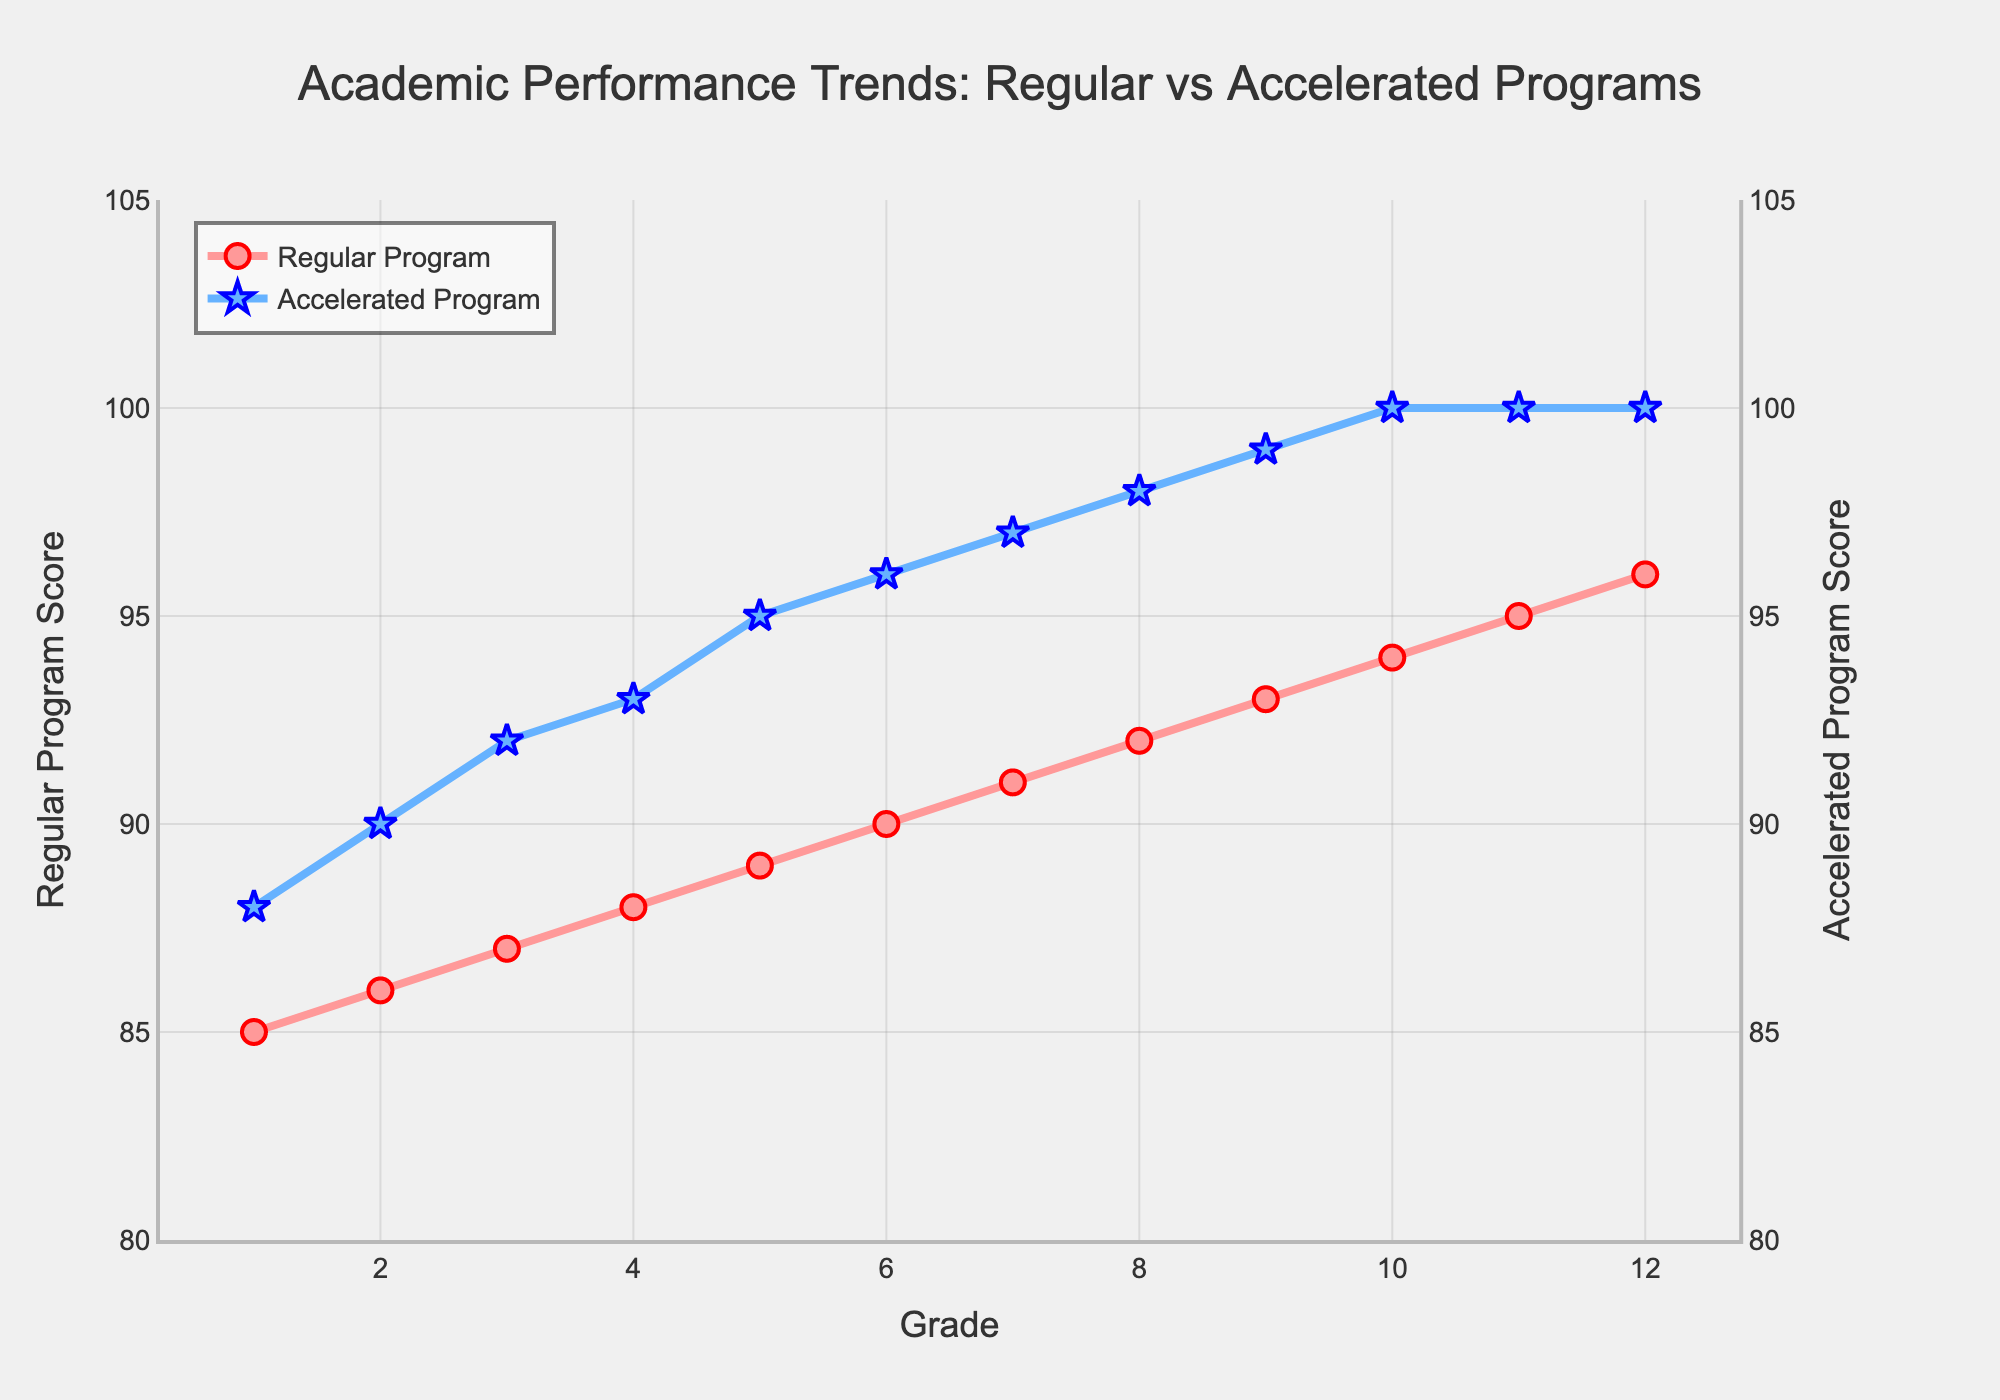Which program shows a more consistent trend in academic performance from grade 1 to grade 12? To determine consistency, observe the smoothness of the line plot. The Regular Program shows a gradual, steady increase in scores, while the Accelerated Program also shows a steady increase but with a slightly more rapid rise. Both are consistent, but the Regular Program has a slightly smoother trend.
Answer: Regular Program At which grade does the Regular Program achieve a score of 90, and how does this compare to the Accelerated Program’s score at the same grade? Look at the plot to find where the Regular Program line intersects the score of 90. This happens at grade 6. The Accelerated Program score at grade 6 is 96.
Answer: Grade 6, 96 What is the difference in performance between the Regular Program and the Accelerated Program at grade 10? At grade 10, observe the y-values for both programs. The Regular Program score is 94, and the Accelerated Program score is 100. Subtract the Regular Program score from the Accelerated Program score: 100 - 94 = 6.
Answer: 6 What is the average performance score of the Accelerated Program from grades 1 through 12? Sum the scores for the Accelerated Program from grades 1 to 12 and divide by 12. (88 + 90 + 92 + 93 + 95 + 96 + 97 + 98 + 99 + 100 + 100 + 100) / 12 = 94.083.
Answer: 94.083 How do the trends of the Regular Program and Accelerated Program differ visually? The Regular Program line is red with circle markers and shows a gradual upward trend. The Accelerated Program line is blue with star markers and shows a steeper upward trend in performance and reaches 100 by grade 10, remaining constant thereafter.
Answer: Red circle markers for Regular Program, blue star markers for Accelerated Program At what grade does the Accelerated Program reach a score of 100, and what is the Regular Program’s score at that grade? The Accelerated Program reaches a score of 100 at grade 10. The Regular Program’s score at grade 10 is 94.
Answer: Grade 10, 94 What is the overall trend in average scores across all grades for both programs? Calculate the average score across all grades for both programs. Regular: (85 + 86 + 87 + 88 + 89 + 90 + 91 + 92 + 93 + 94 + 95 + 96) / 12 = 90.25. Accelerated: (88 + 90 + 92 + 93 + 95 + 96 + 97 + 98 + 99 + 100 + 100 + 100) / 12 = 94.083. Both show an increasing trend, with the Accelerated Program having a higher average.
Answer: Increasing, Accelerated Program higher Between grades 1 and 5, which program shows a greater increase in performance? Calculate the increase for each program from grade 1 to 5. Regular: (89 - 85) = 4. Accelerated: (95 - 88) = 7. The Accelerated Program shows a greater increase.
Answer: Accelerated Program What is the steepest increase observed in the Regular Program, and in which grade does it occur? Observe the change in score for each consecutive grade in the Regular Program. The steepest increase is from grade 1 to grade 2, where the score increases by 1.
Answer: Grade 1 to 2 What are the final scores for both programs at grade 12? Look at the y-values at grade 12 for both lines. The Regular Program’s score is 96, and the Accelerated Program’s score is 100.
Answer: 96, 100 